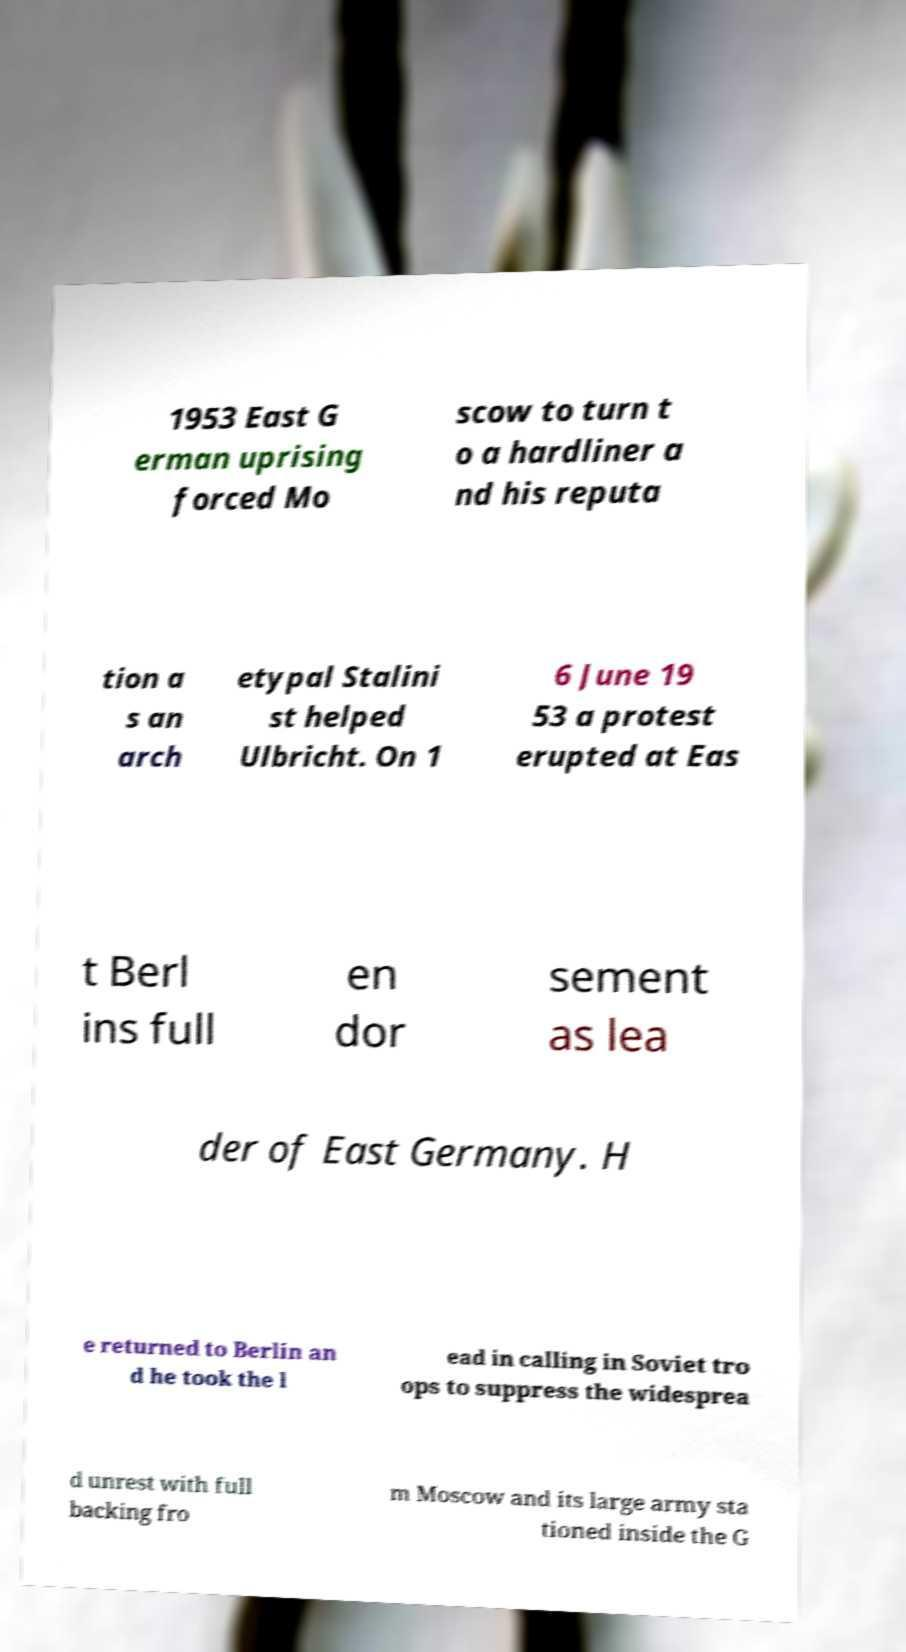I need the written content from this picture converted into text. Can you do that? 1953 East G erman uprising forced Mo scow to turn t o a hardliner a nd his reputa tion a s an arch etypal Stalini st helped Ulbricht. On 1 6 June 19 53 a protest erupted at Eas t Berl ins full en dor sement as lea der of East Germany. H e returned to Berlin an d he took the l ead in calling in Soviet tro ops to suppress the widesprea d unrest with full backing fro m Moscow and its large army sta tioned inside the G 